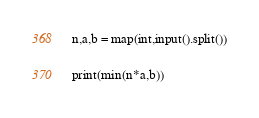Convert code to text. <code><loc_0><loc_0><loc_500><loc_500><_Python_>n,a,b = map(int,input().split())

print(min(n*a,b))</code> 